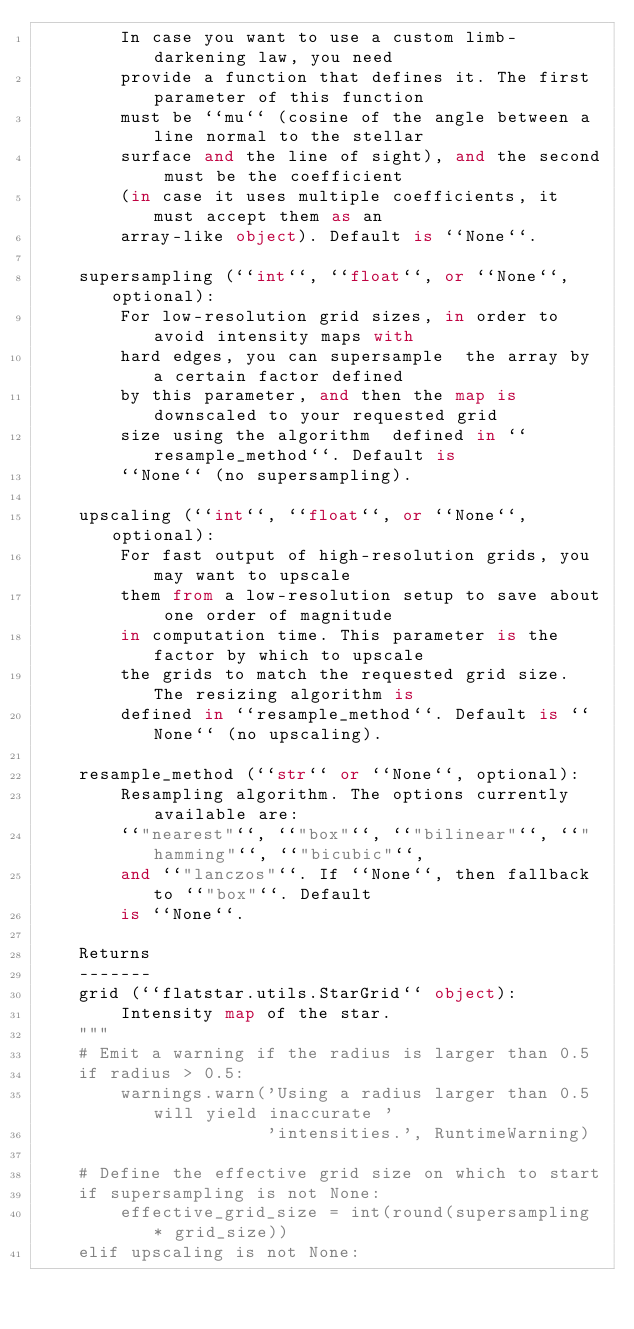Convert code to text. <code><loc_0><loc_0><loc_500><loc_500><_Python_>        In case you want to use a custom limb-darkening law, you need
        provide a function that defines it. The first parameter of this function
        must be ``mu`` (cosine of the angle between a line normal to the stellar
        surface and the line of sight), and the second must be the coefficient
        (in case it uses multiple coefficients, it must accept them as an
        array-like object). Default is ``None``.

    supersampling (``int``, ``float``, or ``None``, optional):
        For low-resolution grid sizes, in order to avoid intensity maps with
        hard edges, you can supersample  the array by a certain factor defined
        by this parameter, and then the map is downscaled to your requested grid
        size using the algorithm  defined in ``resample_method``. Default is
        ``None`` (no supersampling).

    upscaling (``int``, ``float``, or ``None``, optional):
        For fast output of high-resolution grids, you may want to upscale
        them from a low-resolution setup to save about one order of magnitude
        in computation time. This parameter is the factor by which to upscale
        the grids to match the requested grid size. The resizing algorithm is
        defined in ``resample_method``. Default is ``None`` (no upscaling).

    resample_method (``str`` or ``None``, optional):
        Resampling algorithm. The options currently available are:
        ``"nearest"``, ``"box"``, ``"bilinear"``, ``"hamming"``, ``"bicubic"``,
        and ``"lanczos"``. If ``None``, then fallback to ``"box"``. Default
        is ``None``.

    Returns
    -------
    grid (``flatstar.utils.StarGrid`` object):
        Intensity map of the star.
    """
    # Emit a warning if the radius is larger than 0.5
    if radius > 0.5:
        warnings.warn('Using a radius larger than 0.5 will yield inaccurate '
                      'intensities.', RuntimeWarning)

    # Define the effective grid size on which to start
    if supersampling is not None:
        effective_grid_size = int(round(supersampling * grid_size))
    elif upscaling is not None:</code> 